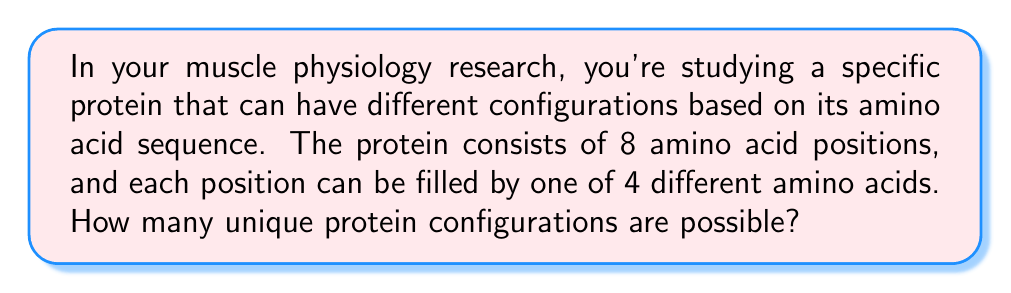Solve this math problem. To solve this problem, we can use the multiplication principle from combinatorics. Here's the step-by-step explanation:

1. We have 8 positions in the protein sequence.
2. For each position, we have 4 choices of amino acids.
3. The choices for each position are independent of the choices for other positions.

Therefore, we can use the multiplication principle, which states that if we have $n$ independent events, and each event $i$ has $k_i$ possible outcomes, then the total number of possible outcomes for all events is the product of the number of possible outcomes for each event.

In this case, we have 8 independent events (the 8 positions), and each event has 4 possible outcomes (the 4 amino acids). So, we can calculate the total number of possible configurations as:

$$ \text{Total configurations} = 4 \times 4 \times 4 \times 4 \times 4 \times 4 \times 4 \times 4 $$

This can be written more concisely as:

$$ \text{Total configurations} = 4^8 $$

Calculating this:

$$ 4^8 = 65,536 $$
Answer: 65,536 unique protein configurations are possible. 